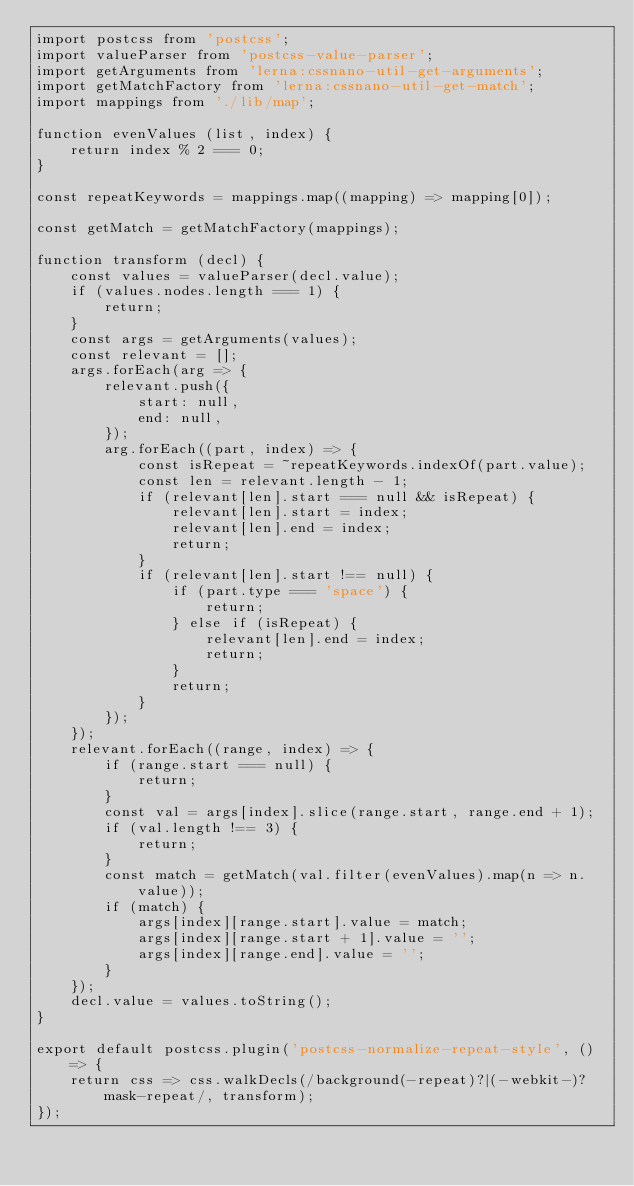<code> <loc_0><loc_0><loc_500><loc_500><_JavaScript_>import postcss from 'postcss';
import valueParser from 'postcss-value-parser';
import getArguments from 'lerna:cssnano-util-get-arguments';
import getMatchFactory from 'lerna:cssnano-util-get-match';
import mappings from './lib/map';

function evenValues (list, index) {
    return index % 2 === 0;
}

const repeatKeywords = mappings.map((mapping) => mapping[0]);

const getMatch = getMatchFactory(mappings);

function transform (decl) {
    const values = valueParser(decl.value);
    if (values.nodes.length === 1) {
        return;
    }
    const args = getArguments(values);
    const relevant = [];
    args.forEach(arg => {
        relevant.push({
            start: null,
            end: null,
        });
        arg.forEach((part, index) => {
            const isRepeat = ~repeatKeywords.indexOf(part.value);
            const len = relevant.length - 1;
            if (relevant[len].start === null && isRepeat) {
                relevant[len].start = index;
                relevant[len].end = index;
                return;
            }
            if (relevant[len].start !== null) {
                if (part.type === 'space') {
                    return;
                } else if (isRepeat) {
                    relevant[len].end = index;
                    return;
                }
                return;
            }
        });
    });
    relevant.forEach((range, index) => {
        if (range.start === null) {
            return;
        }
        const val = args[index].slice(range.start, range.end + 1);
        if (val.length !== 3) {
            return;
        }
        const match = getMatch(val.filter(evenValues).map(n => n.value));
        if (match) {
            args[index][range.start].value = match;
            args[index][range.start + 1].value = '';
            args[index][range.end].value = '';
        }
    });
    decl.value = values.toString();
}

export default postcss.plugin('postcss-normalize-repeat-style', () => {
    return css => css.walkDecls(/background(-repeat)?|(-webkit-)?mask-repeat/, transform);
});
</code> 